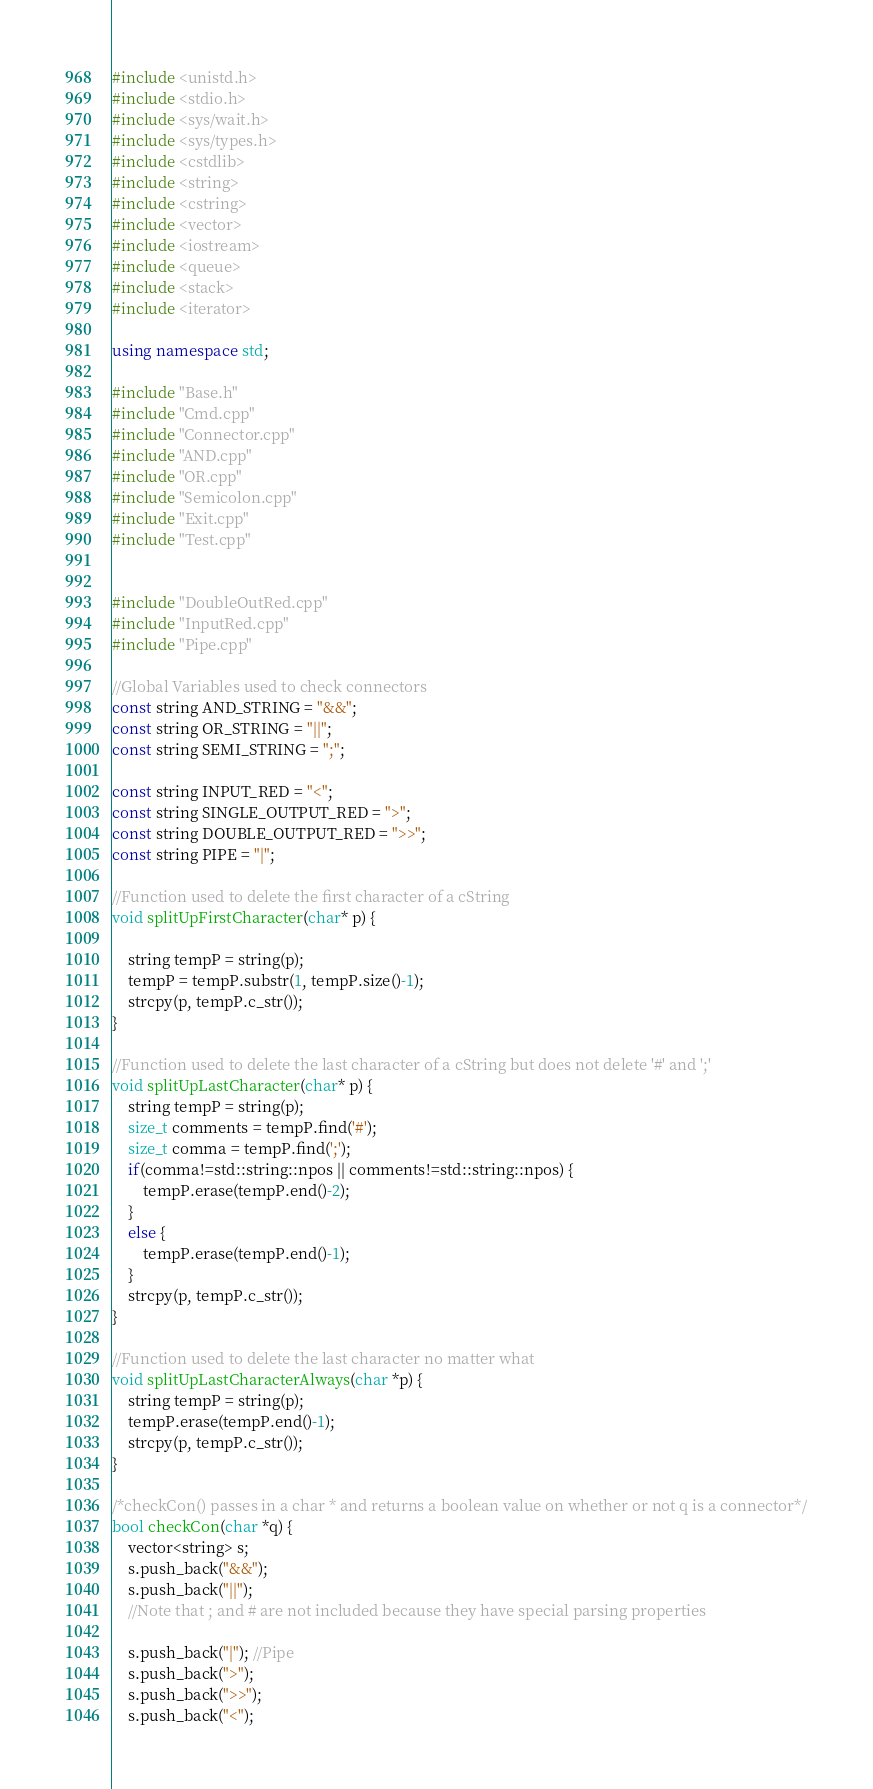<code> <loc_0><loc_0><loc_500><loc_500><_C++_>#include <unistd.h>
#include <stdio.h>
#include <sys/wait.h>
#include <sys/types.h>
#include <cstdlib>
#include <string>
#include <cstring>
#include <vector>
#include <iostream>
#include <queue>
#include <stack>
#include <iterator>

using namespace std;

#include "Base.h"
#include "Cmd.cpp"
#include "Connector.cpp"
#include "AND.cpp"
#include "OR.cpp"
#include "Semicolon.cpp"
#include "Exit.cpp"
#include "Test.cpp"


#include "DoubleOutRed.cpp"
#include "InputRed.cpp"
#include "Pipe.cpp"

//Global Variables used to check connectors
const string AND_STRING = "&&";
const string OR_STRING = "||";
const string SEMI_STRING = ";";

const string INPUT_RED = "<";
const string SINGLE_OUTPUT_RED = ">";
const string DOUBLE_OUTPUT_RED = ">>";
const string PIPE = "|";

//Function used to delete the first character of a cString
void splitUpFirstCharacter(char* p) {

    string tempP = string(p);
    tempP = tempP.substr(1, tempP.size()-1);
    strcpy(p, tempP.c_str());
}

//Function used to delete the last character of a cString but does not delete '#' and ';'
void splitUpLastCharacter(char* p) {
    string tempP = string(p);
    size_t comments = tempP.find('#');
    size_t comma = tempP.find(';');
    if(comma!=std::string::npos || comments!=std::string::npos) {
        tempP.erase(tempP.end()-2);
    }
    else {
        tempP.erase(tempP.end()-1);
    }
    strcpy(p, tempP.c_str());
}

//Function used to delete the last character no matter what
void splitUpLastCharacterAlways(char *p) {
    string tempP = string(p);
    tempP.erase(tempP.end()-1);
    strcpy(p, tempP.c_str());
}

/*checkCon() passes in a char * and returns a boolean value on whether or not q is a connector*/
bool checkCon(char *q) {
    vector<string> s;
    s.push_back("&&");
    s.push_back("||");
    //Note that ; and # are not included because they have special parsing properties

    s.push_back("|"); //Pipe
    s.push_back(">");
    s.push_back(">>");
    s.push_back("<");</code> 